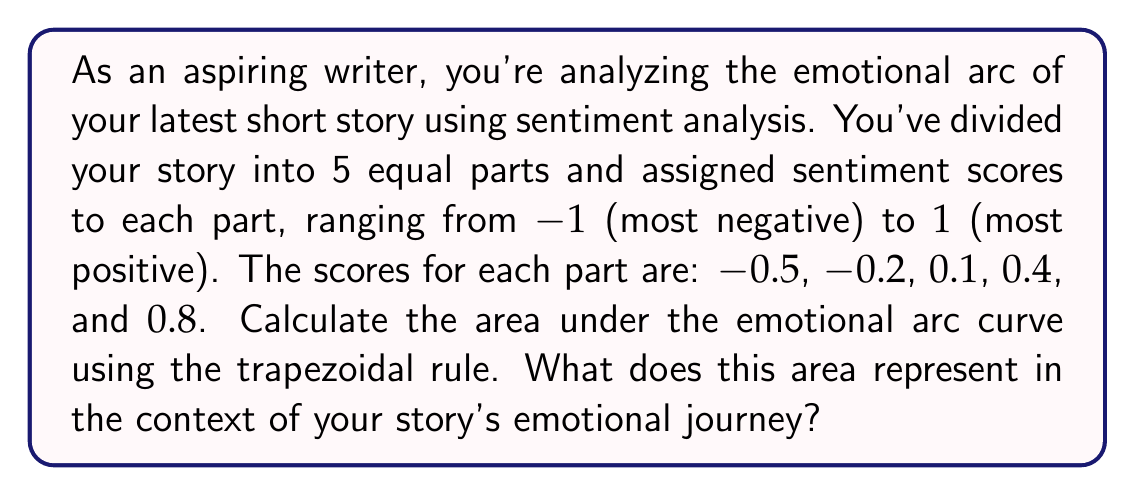Can you answer this question? To solve this problem, we'll use the trapezoidal rule for numerical integration. The trapezoidal rule approximates the area under a curve by dividing it into trapezoids.

The formula for the trapezoidal rule is:

$$\int_{a}^{b} f(x) dx \approx \frac{h}{2} \left[f(x_0) + 2f(x_1) + 2f(x_2) + ... + 2f(x_{n-1}) + f(x_n)\right]$$

Where $h$ is the width of each trapezoid, $n$ is the number of trapezoids, and $f(x_i)$ are the function values at each point.

In this case:
- We have 5 parts, so $n = 4$ (number of trapezoids)
- Each part represents 0.2 of the story (assuming the story is normalized to a length of 1)
- The sentiment scores are the $f(x_i)$ values

Let's apply the formula:

$$\text{Area} = \frac{0.2}{2} \left[(-0.5) + 2(-0.2) + 2(0.1) + 2(0.4) + 0.8\right]$$

$$= 0.1 \left[-0.5 - 0.4 + 0.2 + 0.8 + 0.8\right]$$

$$= 0.1 \left[0.9\right]$$

$$= 0.09$$

This area represents the cumulative emotional impact of the story. A positive area indicates that the story ends on a more positive note than it began, suggesting an overall uplifting emotional journey. The magnitude of the area (0.09 in this case) represents the intensity of this emotional shift.
Answer: The area under the emotional arc curve is 0.09. This positive value indicates that the story has an overall upward emotional trajectory, ending more positively than it began. The relatively small magnitude suggests a moderate emotional shift throughout the narrative. 